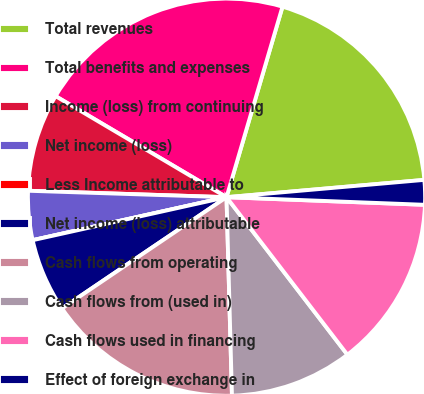<chart> <loc_0><loc_0><loc_500><loc_500><pie_chart><fcel>Total revenues<fcel>Total benefits and expenses<fcel>Income (loss) from continuing<fcel>Net income (loss)<fcel>Less Income attributable to<fcel>Net income (loss) attributable<fcel>Cash flows from operating<fcel>Cash flows from (used in)<fcel>Cash flows used in financing<fcel>Effect of foreign exchange in<nl><fcel>19.06%<fcel>21.05%<fcel>7.98%<fcel>3.99%<fcel>0.0%<fcel>5.99%<fcel>15.97%<fcel>9.98%<fcel>13.97%<fcel>2.0%<nl></chart> 